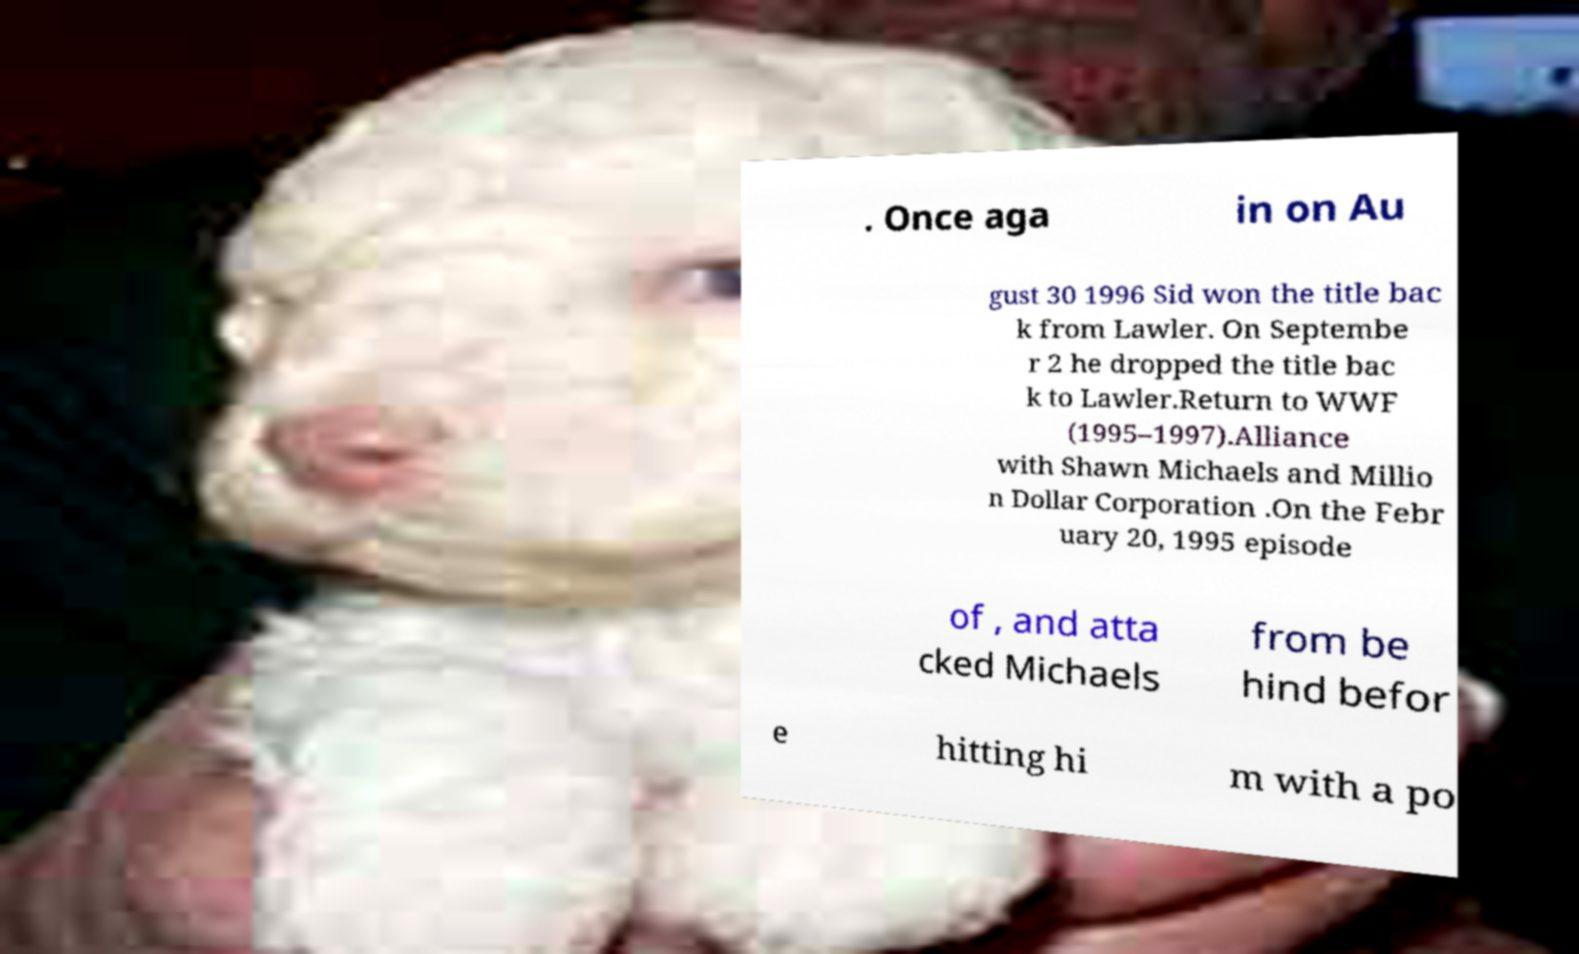Please read and relay the text visible in this image. What does it say? . Once aga in on Au gust 30 1996 Sid won the title bac k from Lawler. On Septembe r 2 he dropped the title bac k to Lawler.Return to WWF (1995–1997).Alliance with Shawn Michaels and Millio n Dollar Corporation .On the Febr uary 20, 1995 episode of , and atta cked Michaels from be hind befor e hitting hi m with a po 